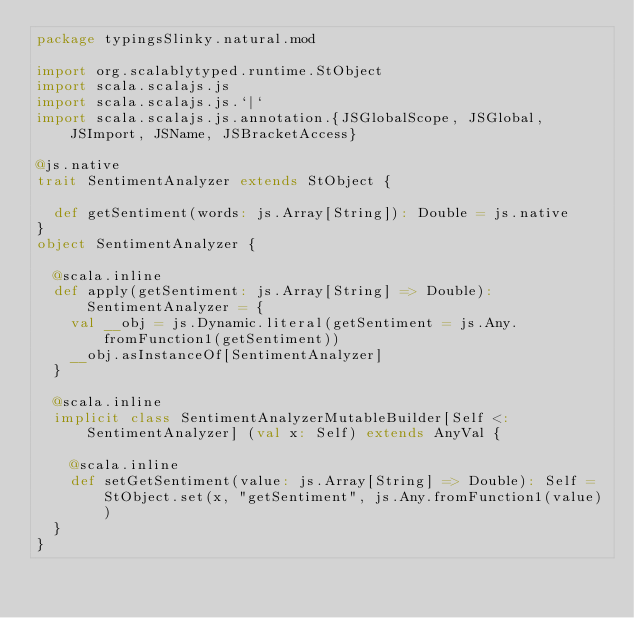<code> <loc_0><loc_0><loc_500><loc_500><_Scala_>package typingsSlinky.natural.mod

import org.scalablytyped.runtime.StObject
import scala.scalajs.js
import scala.scalajs.js.`|`
import scala.scalajs.js.annotation.{JSGlobalScope, JSGlobal, JSImport, JSName, JSBracketAccess}

@js.native
trait SentimentAnalyzer extends StObject {
  
  def getSentiment(words: js.Array[String]): Double = js.native
}
object SentimentAnalyzer {
  
  @scala.inline
  def apply(getSentiment: js.Array[String] => Double): SentimentAnalyzer = {
    val __obj = js.Dynamic.literal(getSentiment = js.Any.fromFunction1(getSentiment))
    __obj.asInstanceOf[SentimentAnalyzer]
  }
  
  @scala.inline
  implicit class SentimentAnalyzerMutableBuilder[Self <: SentimentAnalyzer] (val x: Self) extends AnyVal {
    
    @scala.inline
    def setGetSentiment(value: js.Array[String] => Double): Self = StObject.set(x, "getSentiment", js.Any.fromFunction1(value))
  }
}
</code> 